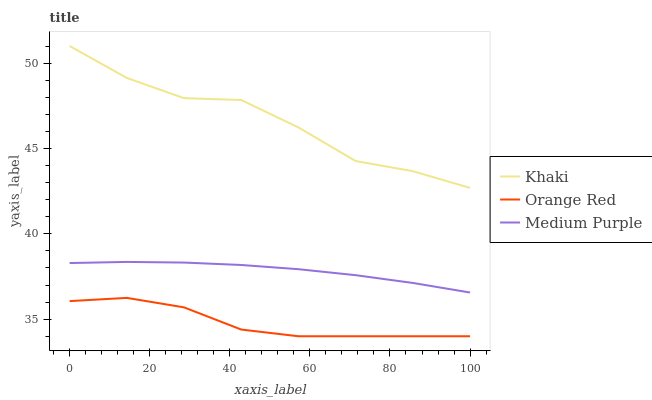Does Orange Red have the minimum area under the curve?
Answer yes or no. Yes. Does Khaki have the maximum area under the curve?
Answer yes or no. Yes. Does Khaki have the minimum area under the curve?
Answer yes or no. No. Does Orange Red have the maximum area under the curve?
Answer yes or no. No. Is Medium Purple the smoothest?
Answer yes or no. Yes. Is Khaki the roughest?
Answer yes or no. Yes. Is Orange Red the smoothest?
Answer yes or no. No. Is Orange Red the roughest?
Answer yes or no. No. Does Orange Red have the lowest value?
Answer yes or no. Yes. Does Khaki have the lowest value?
Answer yes or no. No. Does Khaki have the highest value?
Answer yes or no. Yes. Does Orange Red have the highest value?
Answer yes or no. No. Is Orange Red less than Medium Purple?
Answer yes or no. Yes. Is Medium Purple greater than Orange Red?
Answer yes or no. Yes. Does Orange Red intersect Medium Purple?
Answer yes or no. No. 